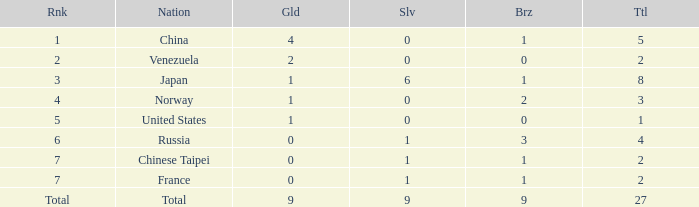What is the Nation when there is a total less than 27, gold is less than 1, and bronze is more than 1? Russia. 